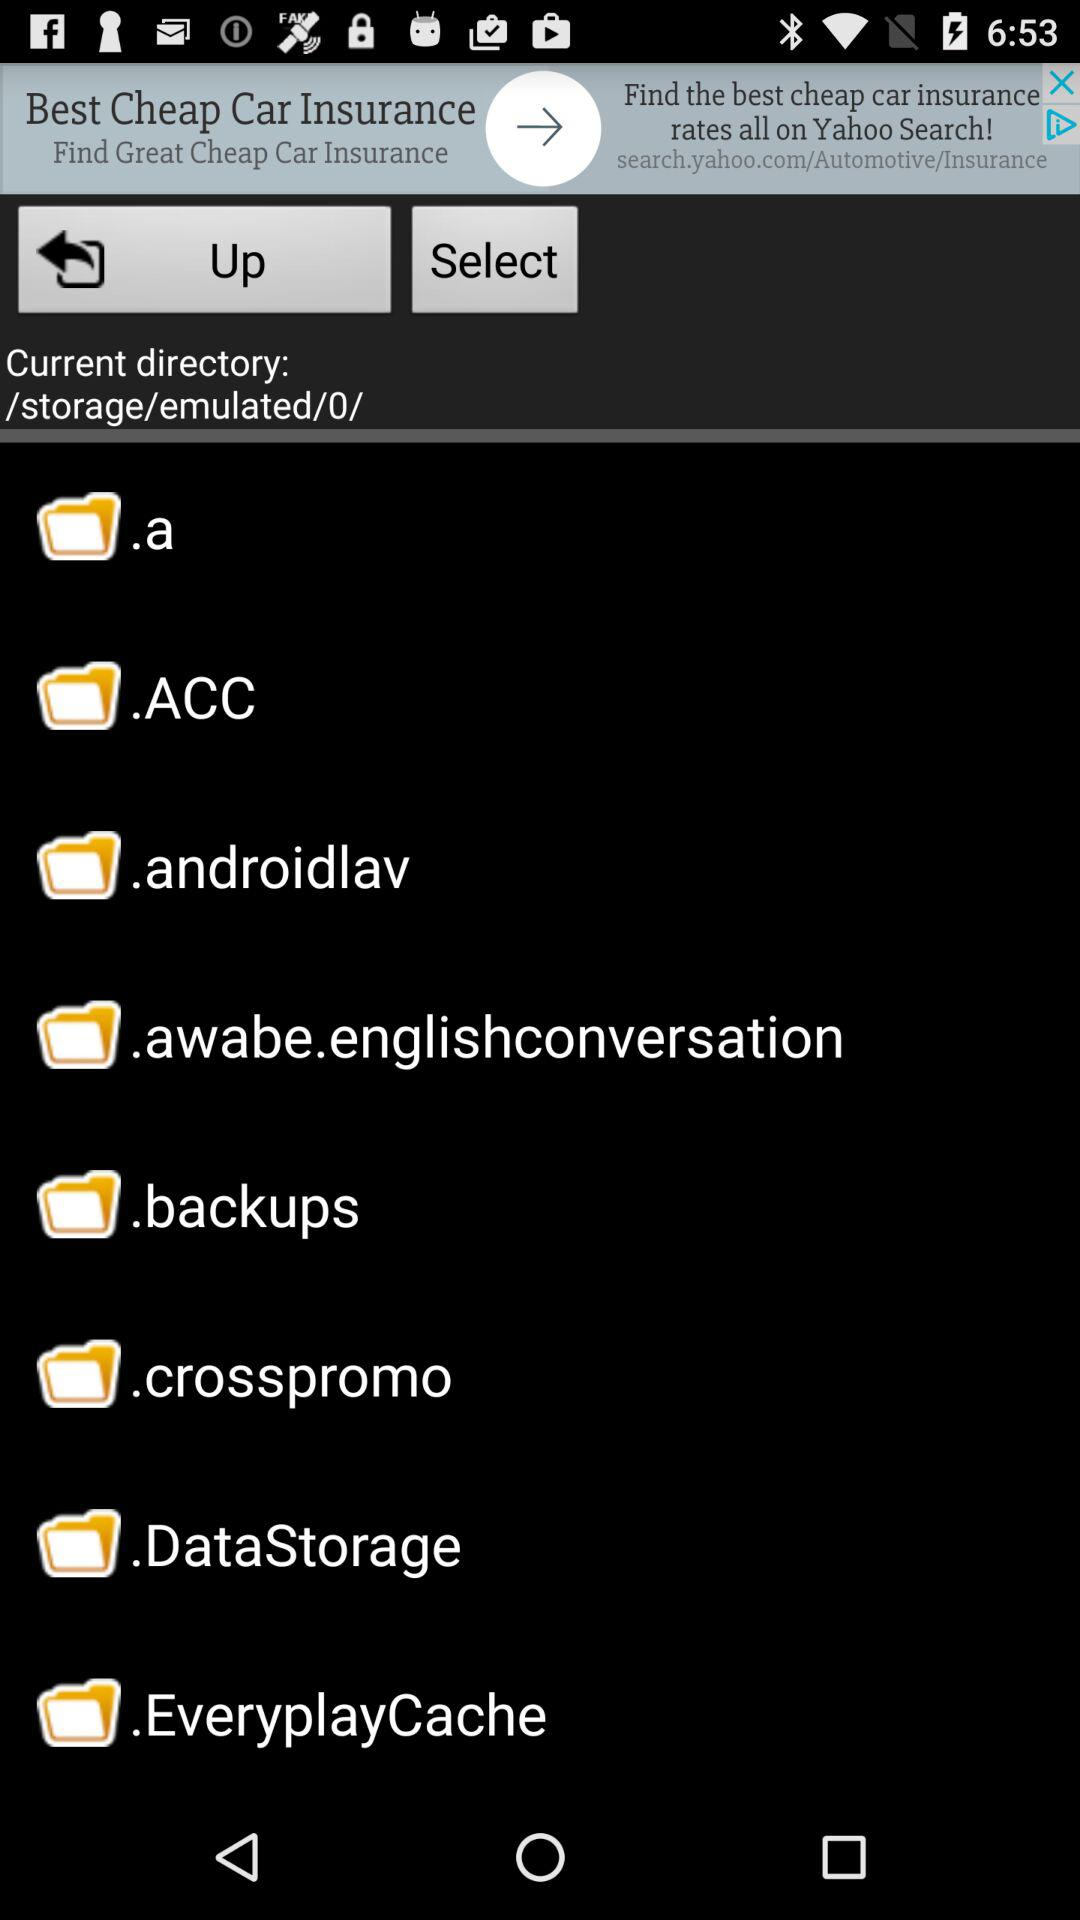How many folders are in the current directory?
Answer the question using a single word or phrase. 8 